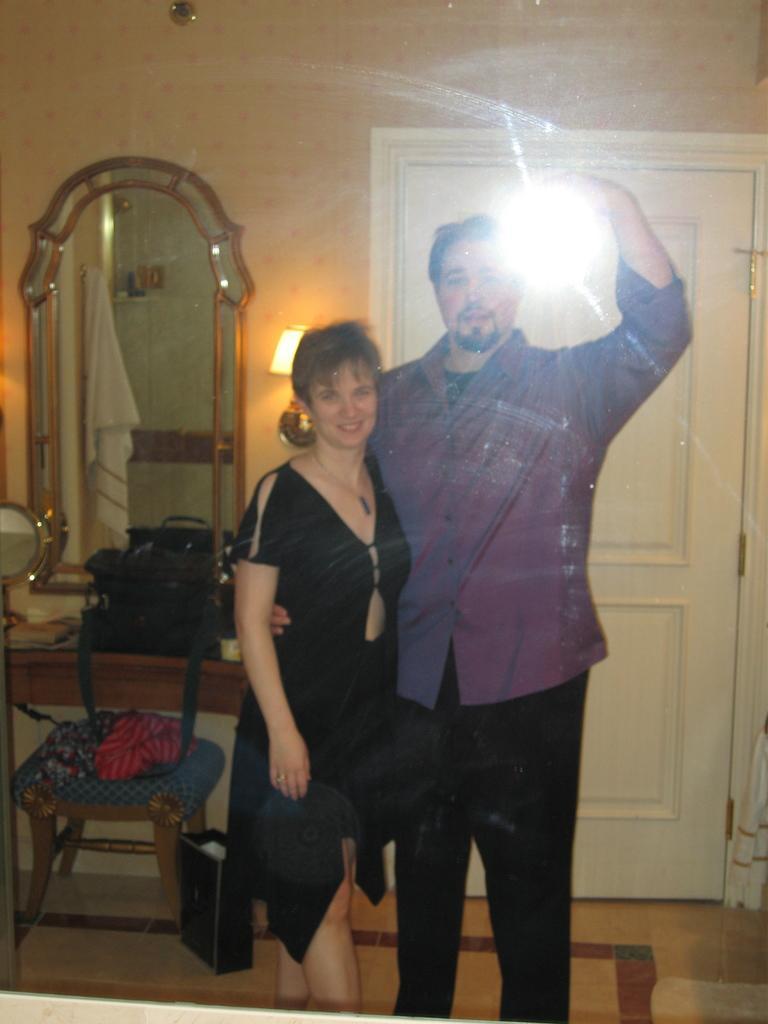Please provide a concise description of this image. In this image we can see man and a woman on the floor. In the background we can see dressing table, wall, door, bag, stool and a mirror. 